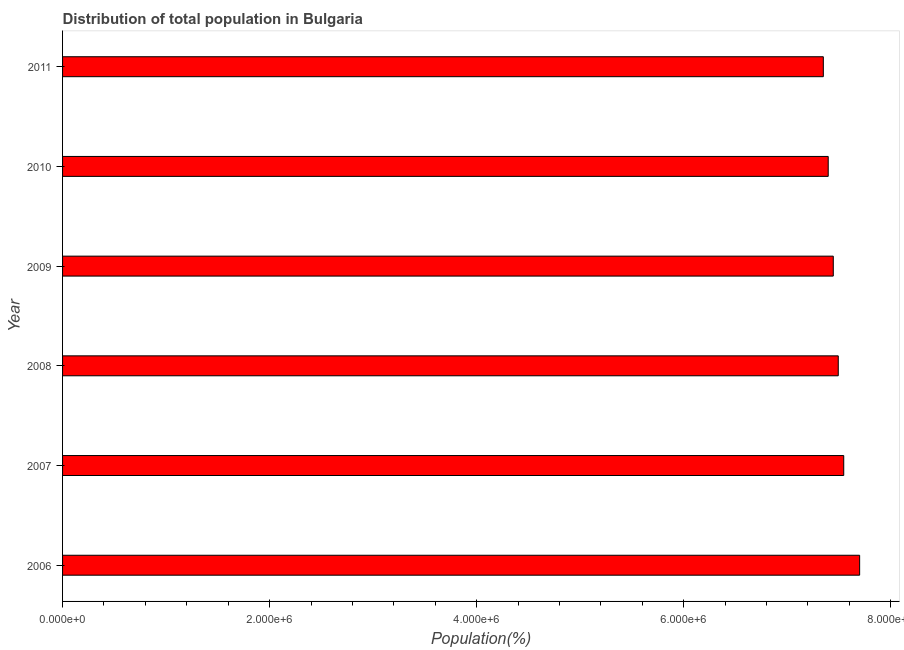What is the title of the graph?
Offer a terse response. Distribution of total population in Bulgaria . What is the label or title of the X-axis?
Ensure brevity in your answer.  Population(%). What is the population in 2007?
Provide a succinct answer. 7.55e+06. Across all years, what is the maximum population?
Give a very brief answer. 7.70e+06. Across all years, what is the minimum population?
Provide a short and direct response. 7.35e+06. In which year was the population minimum?
Ensure brevity in your answer.  2011. What is the sum of the population?
Your answer should be very brief. 4.49e+07. What is the difference between the population in 2006 and 2009?
Your answer should be very brief. 2.55e+05. What is the average population per year?
Provide a short and direct response. 7.49e+06. What is the median population?
Make the answer very short. 7.47e+06. In how many years, is the population greater than 1600000 %?
Offer a very short reply. 6. Do a majority of the years between 2008 and 2006 (inclusive) have population greater than 4000000 %?
Provide a short and direct response. Yes. What is the ratio of the population in 2006 to that in 2010?
Offer a very short reply. 1.04. Is the difference between the population in 2008 and 2009 greater than the difference between any two years?
Give a very brief answer. No. What is the difference between the highest and the second highest population?
Provide a succinct answer. 1.54e+05. Is the sum of the population in 2006 and 2007 greater than the maximum population across all years?
Provide a short and direct response. Yes. What is the difference between the highest and the lowest population?
Your answer should be compact. 3.51e+05. In how many years, is the population greater than the average population taken over all years?
Ensure brevity in your answer.  3. How many years are there in the graph?
Your response must be concise. 6. Are the values on the major ticks of X-axis written in scientific E-notation?
Provide a succinct answer. Yes. What is the Population(%) of 2006?
Your answer should be very brief. 7.70e+06. What is the Population(%) of 2007?
Ensure brevity in your answer.  7.55e+06. What is the Population(%) in 2008?
Your response must be concise. 7.49e+06. What is the Population(%) in 2009?
Make the answer very short. 7.44e+06. What is the Population(%) of 2010?
Keep it short and to the point. 7.40e+06. What is the Population(%) in 2011?
Offer a terse response. 7.35e+06. What is the difference between the Population(%) in 2006 and 2007?
Provide a short and direct response. 1.54e+05. What is the difference between the Population(%) in 2006 and 2008?
Provide a short and direct response. 2.06e+05. What is the difference between the Population(%) in 2006 and 2009?
Your answer should be very brief. 2.55e+05. What is the difference between the Population(%) in 2006 and 2010?
Ensure brevity in your answer.  3.03e+05. What is the difference between the Population(%) in 2006 and 2011?
Provide a succinct answer. 3.51e+05. What is the difference between the Population(%) in 2007 and 2008?
Make the answer very short. 5.28e+04. What is the difference between the Population(%) in 2007 and 2009?
Your answer should be very brief. 1.01e+05. What is the difference between the Population(%) in 2007 and 2010?
Your answer should be very brief. 1.50e+05. What is the difference between the Population(%) in 2007 and 2011?
Offer a terse response. 1.97e+05. What is the difference between the Population(%) in 2008 and 2009?
Make the answer very short. 4.81e+04. What is the difference between the Population(%) in 2008 and 2010?
Offer a very short reply. 9.70e+04. What is the difference between the Population(%) in 2008 and 2011?
Your response must be concise. 1.44e+05. What is the difference between the Population(%) in 2009 and 2010?
Make the answer very short. 4.88e+04. What is the difference between the Population(%) in 2009 and 2011?
Your response must be concise. 9.61e+04. What is the difference between the Population(%) in 2010 and 2011?
Your response must be concise. 4.73e+04. What is the ratio of the Population(%) in 2006 to that in 2008?
Offer a terse response. 1.03. What is the ratio of the Population(%) in 2006 to that in 2009?
Keep it short and to the point. 1.03. What is the ratio of the Population(%) in 2006 to that in 2010?
Your answer should be compact. 1.04. What is the ratio of the Population(%) in 2006 to that in 2011?
Offer a terse response. 1.05. What is the ratio of the Population(%) in 2007 to that in 2008?
Your response must be concise. 1.01. What is the ratio of the Population(%) in 2007 to that in 2009?
Provide a short and direct response. 1.01. What is the ratio of the Population(%) in 2007 to that in 2010?
Offer a very short reply. 1.02. What is the ratio of the Population(%) in 2007 to that in 2011?
Provide a short and direct response. 1.03. What is the ratio of the Population(%) in 2008 to that in 2009?
Offer a very short reply. 1.01. What is the ratio of the Population(%) in 2008 to that in 2011?
Your response must be concise. 1.02. What is the ratio of the Population(%) in 2009 to that in 2010?
Give a very brief answer. 1.01. 